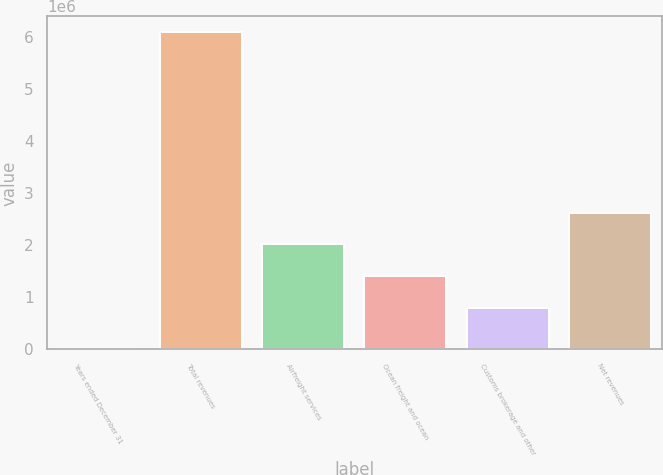<chart> <loc_0><loc_0><loc_500><loc_500><bar_chart><fcel>Years ended December 31<fcel>Total revenues<fcel>Airfreight services<fcel>Ocean freight and ocean<fcel>Customs brokerage and other<fcel>Net revenues<nl><fcel>2016<fcel>6.09804e+06<fcel>2.02234e+06<fcel>1.41274e+06<fcel>803135<fcel>2.63194e+06<nl></chart> 